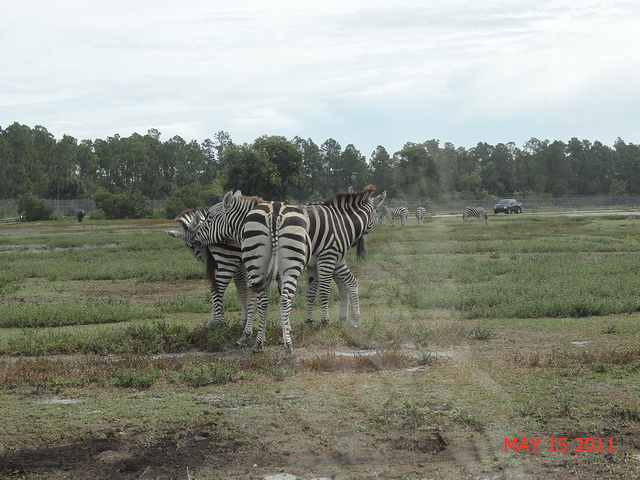How many zebras are in the picture? In the photograph, there are three zebras standing in a field with their stripes visually blending together. This natural camouflage can make it a little challenging to distinguish the individuals, but upon closer inspection, you can see the distinct heads and bodies of each zebra. 